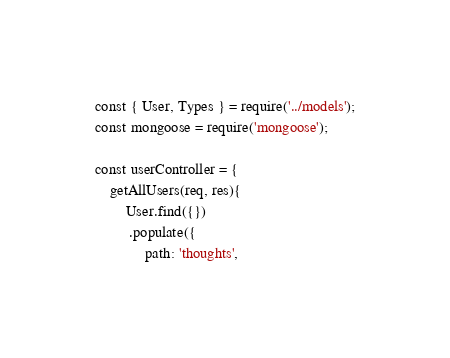Convert code to text. <code><loc_0><loc_0><loc_500><loc_500><_JavaScript_>const { User, Types } = require('../models');
const mongoose = require('mongoose');

const userController = {
    getAllUsers(req, res){
        User.find({})
         .populate({
             path: 'thoughts',</code> 